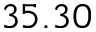Convert formula to latex. <formula><loc_0><loc_0><loc_500><loc_500>3 5 . 3 0</formula> 